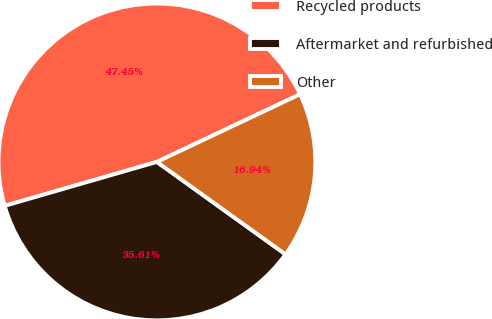Convert chart. <chart><loc_0><loc_0><loc_500><loc_500><pie_chart><fcel>Recycled products<fcel>Aftermarket and refurbished<fcel>Other<nl><fcel>47.45%<fcel>35.61%<fcel>16.94%<nl></chart> 